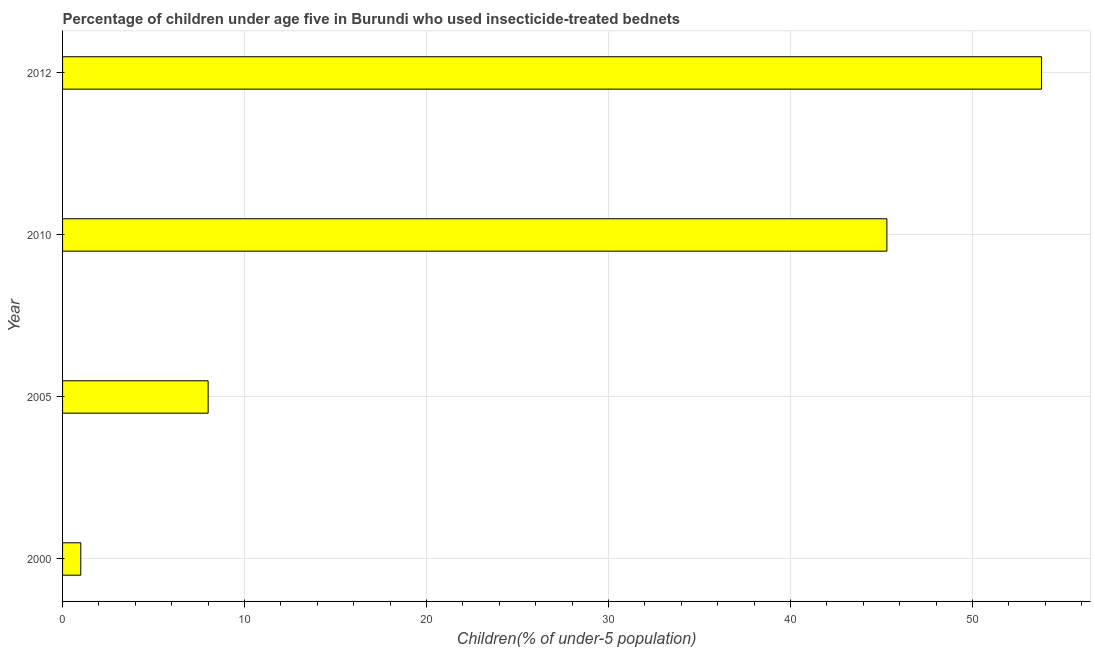Does the graph contain any zero values?
Your answer should be very brief. No. What is the title of the graph?
Make the answer very short. Percentage of children under age five in Burundi who used insecticide-treated bednets. What is the label or title of the X-axis?
Give a very brief answer. Children(% of under-5 population). Across all years, what is the maximum percentage of children who use of insecticide-treated bed nets?
Your answer should be compact. 53.8. Across all years, what is the minimum percentage of children who use of insecticide-treated bed nets?
Provide a short and direct response. 1. In which year was the percentage of children who use of insecticide-treated bed nets maximum?
Your answer should be compact. 2012. What is the sum of the percentage of children who use of insecticide-treated bed nets?
Your answer should be very brief. 108.1. What is the difference between the percentage of children who use of insecticide-treated bed nets in 2005 and 2010?
Your answer should be very brief. -37.3. What is the average percentage of children who use of insecticide-treated bed nets per year?
Keep it short and to the point. 27.02. What is the median percentage of children who use of insecticide-treated bed nets?
Your answer should be very brief. 26.65. In how many years, is the percentage of children who use of insecticide-treated bed nets greater than 18 %?
Give a very brief answer. 2. Do a majority of the years between 2012 and 2005 (inclusive) have percentage of children who use of insecticide-treated bed nets greater than 50 %?
Provide a short and direct response. Yes. What is the ratio of the percentage of children who use of insecticide-treated bed nets in 2000 to that in 2012?
Make the answer very short. 0.02. What is the difference between the highest and the lowest percentage of children who use of insecticide-treated bed nets?
Offer a terse response. 52.8. How many bars are there?
Your response must be concise. 4. Are all the bars in the graph horizontal?
Give a very brief answer. Yes. How many years are there in the graph?
Give a very brief answer. 4. What is the Children(% of under-5 population) in 2000?
Keep it short and to the point. 1. What is the Children(% of under-5 population) of 2005?
Keep it short and to the point. 8. What is the Children(% of under-5 population) of 2010?
Your answer should be very brief. 45.3. What is the Children(% of under-5 population) in 2012?
Offer a very short reply. 53.8. What is the difference between the Children(% of under-5 population) in 2000 and 2010?
Offer a terse response. -44.3. What is the difference between the Children(% of under-5 population) in 2000 and 2012?
Keep it short and to the point. -52.8. What is the difference between the Children(% of under-5 population) in 2005 and 2010?
Your answer should be very brief. -37.3. What is the difference between the Children(% of under-5 population) in 2005 and 2012?
Give a very brief answer. -45.8. What is the ratio of the Children(% of under-5 population) in 2000 to that in 2010?
Provide a short and direct response. 0.02. What is the ratio of the Children(% of under-5 population) in 2000 to that in 2012?
Offer a very short reply. 0.02. What is the ratio of the Children(% of under-5 population) in 2005 to that in 2010?
Offer a very short reply. 0.18. What is the ratio of the Children(% of under-5 population) in 2005 to that in 2012?
Give a very brief answer. 0.15. What is the ratio of the Children(% of under-5 population) in 2010 to that in 2012?
Your response must be concise. 0.84. 